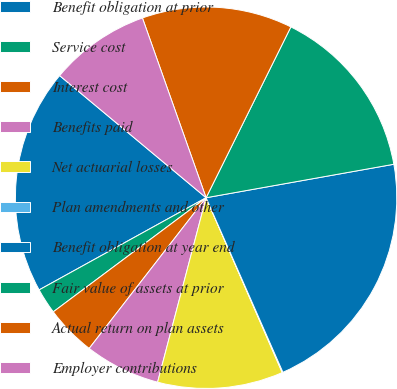Convert chart to OTSL. <chart><loc_0><loc_0><loc_500><loc_500><pie_chart><fcel>Benefit obligation at prior<fcel>Service cost<fcel>Interest cost<fcel>Benefits paid<fcel>Net actuarial losses<fcel>Plan amendments and other<fcel>Benefit obligation at year end<fcel>Fair value of assets at prior<fcel>Actual return on plan assets<fcel>Employer contributions<nl><fcel>19.09%<fcel>2.18%<fcel>4.29%<fcel>6.41%<fcel>10.63%<fcel>0.06%<fcel>21.21%<fcel>14.86%<fcel>12.75%<fcel>8.52%<nl></chart> 